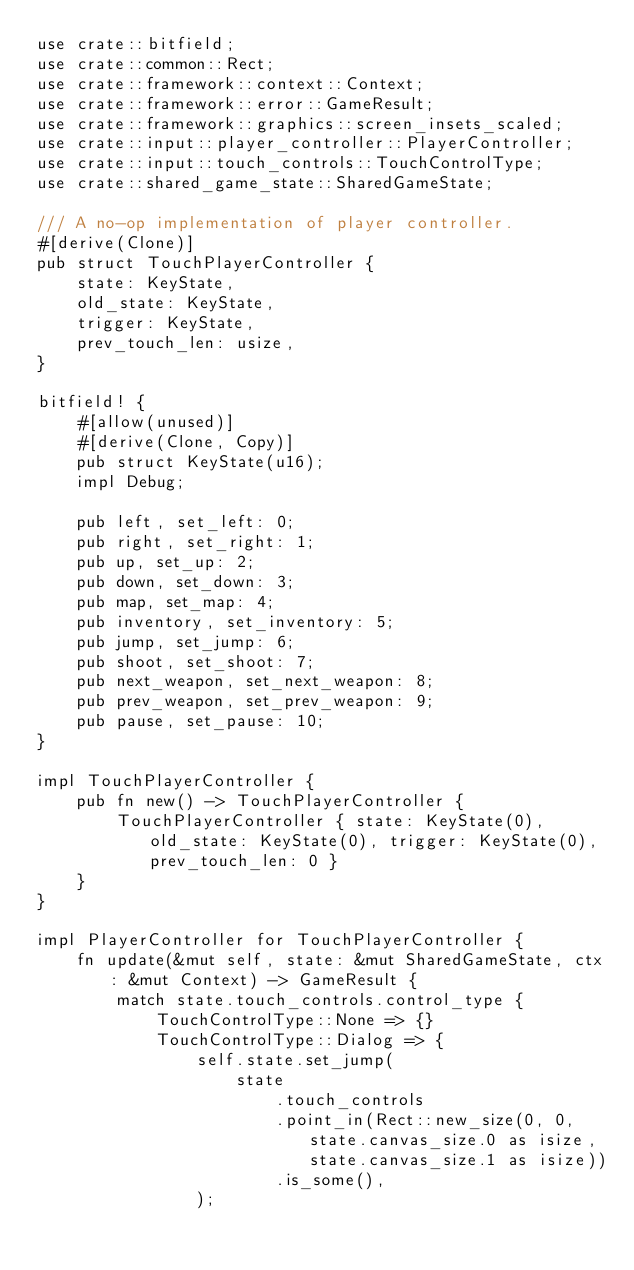Convert code to text. <code><loc_0><loc_0><loc_500><loc_500><_Rust_>use crate::bitfield;
use crate::common::Rect;
use crate::framework::context::Context;
use crate::framework::error::GameResult;
use crate::framework::graphics::screen_insets_scaled;
use crate::input::player_controller::PlayerController;
use crate::input::touch_controls::TouchControlType;
use crate::shared_game_state::SharedGameState;

/// A no-op implementation of player controller.
#[derive(Clone)]
pub struct TouchPlayerController {
    state: KeyState,
    old_state: KeyState,
    trigger: KeyState,
    prev_touch_len: usize,
}

bitfield! {
    #[allow(unused)]
    #[derive(Clone, Copy)]
    pub struct KeyState(u16);
    impl Debug;

    pub left, set_left: 0;
    pub right, set_right: 1;
    pub up, set_up: 2;
    pub down, set_down: 3;
    pub map, set_map: 4;
    pub inventory, set_inventory: 5;
    pub jump, set_jump: 6;
    pub shoot, set_shoot: 7;
    pub next_weapon, set_next_weapon: 8;
    pub prev_weapon, set_prev_weapon: 9;
    pub pause, set_pause: 10;
}

impl TouchPlayerController {
    pub fn new() -> TouchPlayerController {
        TouchPlayerController { state: KeyState(0), old_state: KeyState(0), trigger: KeyState(0), prev_touch_len: 0 }
    }
}

impl PlayerController for TouchPlayerController {
    fn update(&mut self, state: &mut SharedGameState, ctx: &mut Context) -> GameResult {
        match state.touch_controls.control_type {
            TouchControlType::None => {}
            TouchControlType::Dialog => {
                self.state.set_jump(
                    state
                        .touch_controls
                        .point_in(Rect::new_size(0, 0, state.canvas_size.0 as isize, state.canvas_size.1 as isize))
                        .is_some(),
                );
</code> 